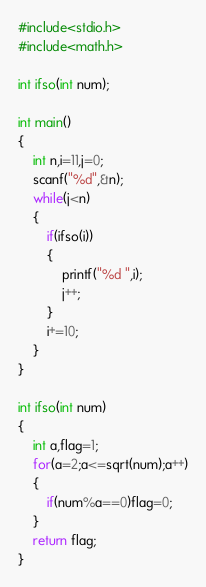<code> <loc_0><loc_0><loc_500><loc_500><_C_>#include<stdio.h>
#include<math.h>

int ifso(int num);

int main()
{
    int n,i=11,j=0;
    scanf("%d",&n);
    while(j<n)
    {
        if(ifso(i))
        {
            printf("%d ",i);
            j++;
        }
        i+=10;
    }
}

int ifso(int num)
{
    int a,flag=1;
    for(a=2;a<=sqrt(num);a++)
    {
        if(num%a==0)flag=0;
    }
    return flag;
}</code> 